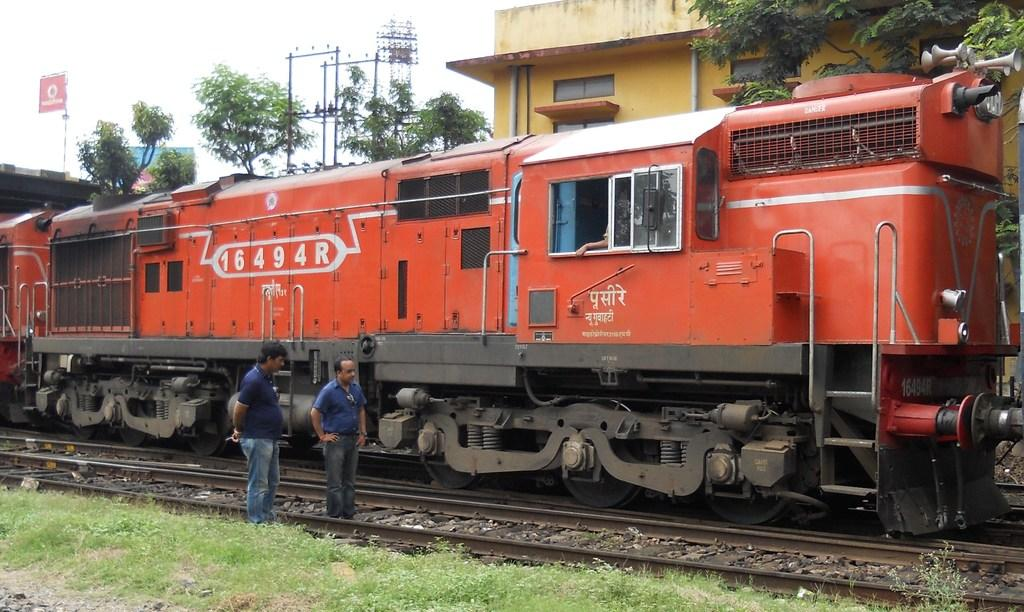<image>
Give a short and clear explanation of the subsequent image. Two men are standing on the tracks near train number 16494R 